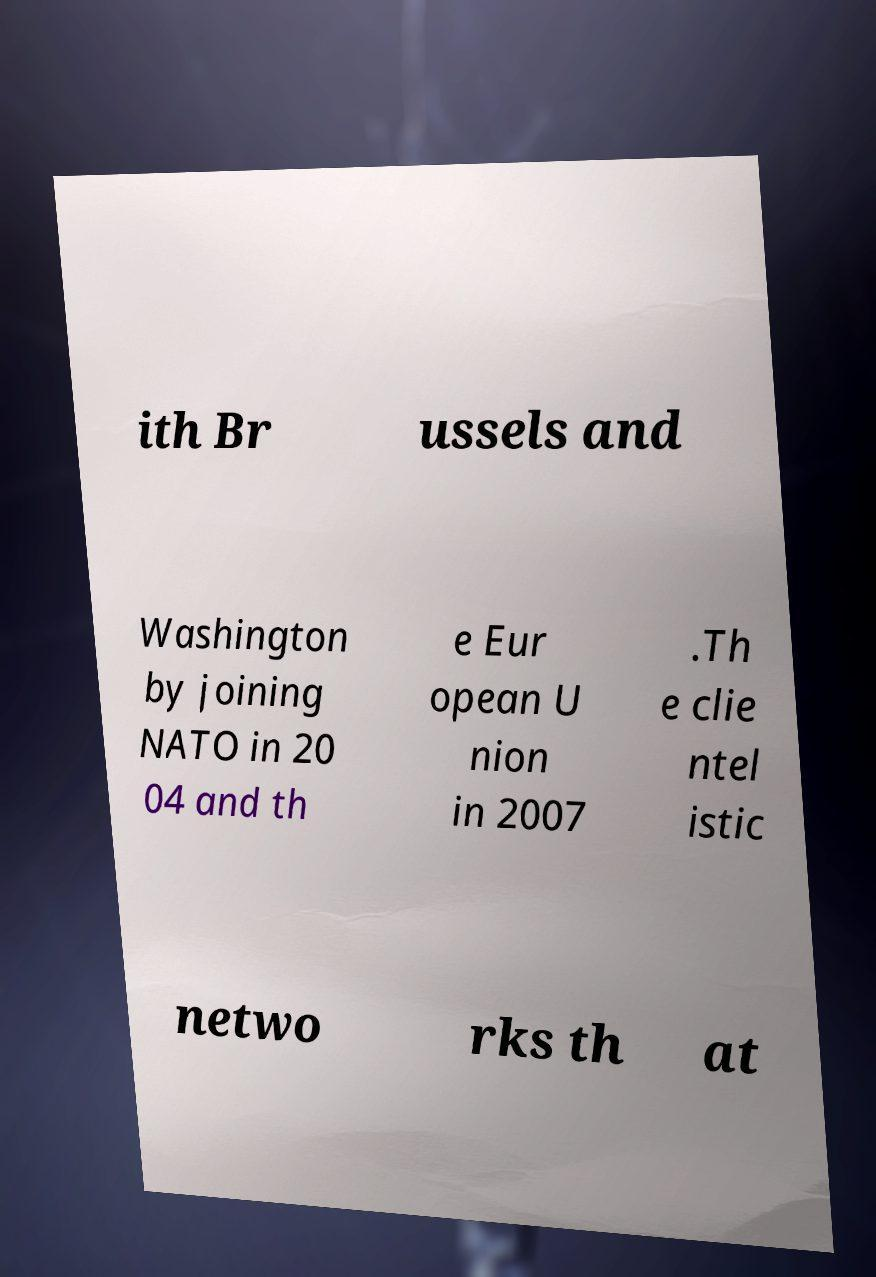Could you assist in decoding the text presented in this image and type it out clearly? ith Br ussels and Washington by joining NATO in 20 04 and th e Eur opean U nion in 2007 .Th e clie ntel istic netwo rks th at 